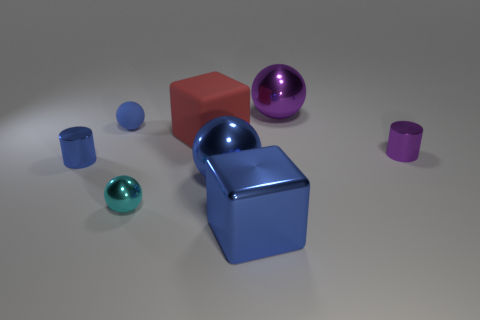There is a block to the right of the large sphere in front of the large purple thing; are there any large metal blocks that are in front of it?
Provide a short and direct response. No. Are any small purple rubber spheres visible?
Ensure brevity in your answer.  No. Does the sphere that is on the right side of the large blue ball have the same material as the blue cylinder behind the big blue metal ball?
Offer a terse response. Yes. There is a metallic cylinder that is on the left side of the metallic sphere that is to the left of the rubber thing on the right side of the cyan shiny sphere; how big is it?
Make the answer very short. Small. What number of small cyan spheres are the same material as the big blue cube?
Ensure brevity in your answer.  1. Are there fewer metallic balls than blue cylinders?
Ensure brevity in your answer.  No. What size is the blue object that is the same shape as the large red matte thing?
Ensure brevity in your answer.  Large. Is the material of the large block that is in front of the tiny purple metallic cylinder the same as the red object?
Make the answer very short. No. Is the cyan thing the same shape as the blue matte object?
Your response must be concise. Yes. How many objects are either small cylinders to the right of the cyan sphere or big things?
Keep it short and to the point. 5. 